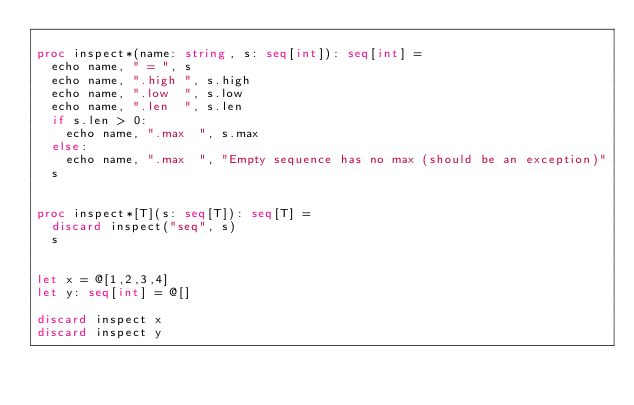<code> <loc_0><loc_0><loc_500><loc_500><_Nim_>
proc inspect*(name: string, s: seq[int]): seq[int] =
  echo name, " = ", s
  echo name, ".high ", s.high
  echo name, ".low  ", s.low
  echo name, ".len  ", s.len
  if s.len > 0:
    echo name, ".max  ", s.max
  else:
    echo name, ".max  ", "Empty sequence has no max (should be an exception)"
  s


proc inspect*[T](s: seq[T]): seq[T] =
  discard inspect("seq", s)
  s


let x = @[1,2,3,4]
let y: seq[int] = @[]

discard inspect x
discard inspect y</code> 